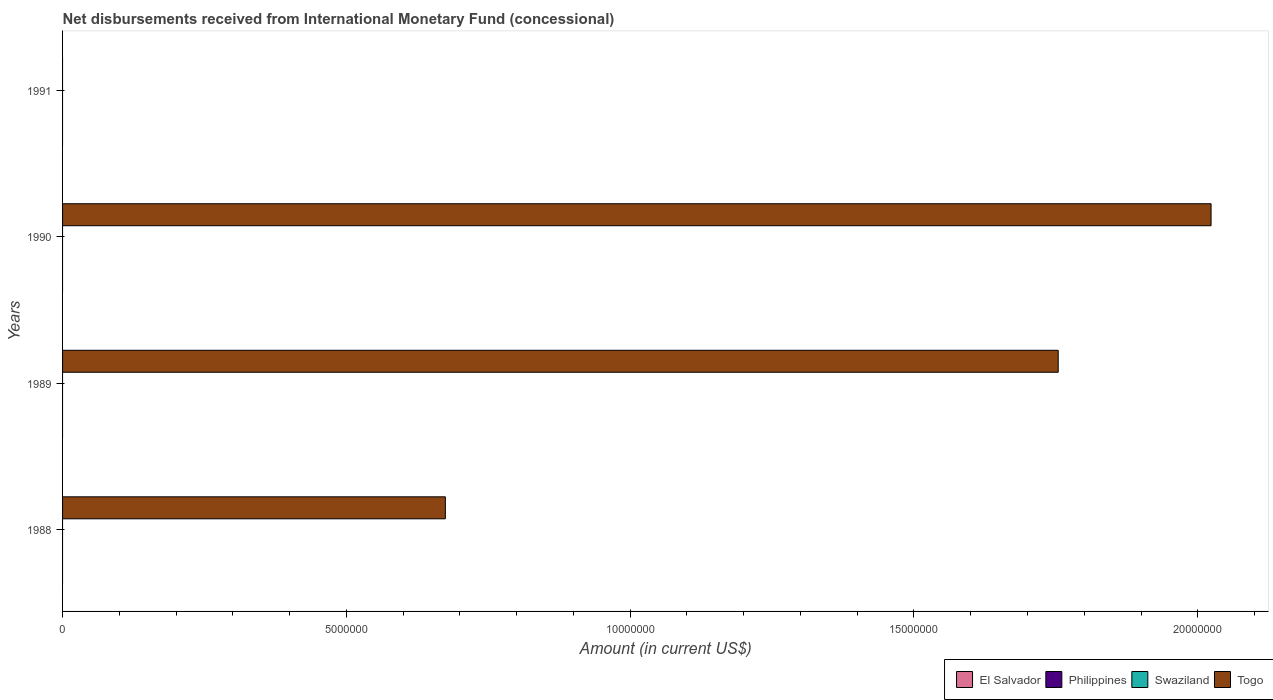How many different coloured bars are there?
Ensure brevity in your answer.  1. How many bars are there on the 1st tick from the bottom?
Ensure brevity in your answer.  1. What is the label of the 1st group of bars from the top?
Offer a terse response. 1991. Across all years, what is the maximum amount of disbursements received from International Monetary Fund in Togo?
Give a very brief answer. 2.02e+07. Across all years, what is the minimum amount of disbursements received from International Monetary Fund in Philippines?
Your answer should be compact. 0. What is the total amount of disbursements received from International Monetary Fund in El Salvador in the graph?
Provide a short and direct response. 0. What is the difference between the amount of disbursements received from International Monetary Fund in Swaziland in 1991 and the amount of disbursements received from International Monetary Fund in Togo in 1989?
Your response must be concise. -1.75e+07. What is the average amount of disbursements received from International Monetary Fund in Swaziland per year?
Provide a short and direct response. 0. What is the ratio of the amount of disbursements received from International Monetary Fund in Togo in 1989 to that in 1990?
Your response must be concise. 0.87. What is the difference between the highest and the second highest amount of disbursements received from International Monetary Fund in Togo?
Your answer should be compact. 2.69e+06. What is the difference between the highest and the lowest amount of disbursements received from International Monetary Fund in Togo?
Your answer should be compact. 2.02e+07. In how many years, is the amount of disbursements received from International Monetary Fund in Togo greater than the average amount of disbursements received from International Monetary Fund in Togo taken over all years?
Your answer should be compact. 2. Is it the case that in every year, the sum of the amount of disbursements received from International Monetary Fund in El Salvador and amount of disbursements received from International Monetary Fund in Swaziland is greater than the sum of amount of disbursements received from International Monetary Fund in Philippines and amount of disbursements received from International Monetary Fund in Togo?
Provide a short and direct response. No. Is it the case that in every year, the sum of the amount of disbursements received from International Monetary Fund in Philippines and amount of disbursements received from International Monetary Fund in El Salvador is greater than the amount of disbursements received from International Monetary Fund in Togo?
Your answer should be compact. No. How many bars are there?
Your answer should be very brief. 3. How many years are there in the graph?
Your response must be concise. 4. What is the difference between two consecutive major ticks on the X-axis?
Make the answer very short. 5.00e+06. Does the graph contain grids?
Your answer should be very brief. No. How are the legend labels stacked?
Make the answer very short. Horizontal. What is the title of the graph?
Ensure brevity in your answer.  Net disbursements received from International Monetary Fund (concessional). Does "Burkina Faso" appear as one of the legend labels in the graph?
Give a very brief answer. No. What is the Amount (in current US$) in El Salvador in 1988?
Provide a succinct answer. 0. What is the Amount (in current US$) in Philippines in 1988?
Your answer should be compact. 0. What is the Amount (in current US$) of Togo in 1988?
Provide a succinct answer. 6.74e+06. What is the Amount (in current US$) in Swaziland in 1989?
Ensure brevity in your answer.  0. What is the Amount (in current US$) in Togo in 1989?
Keep it short and to the point. 1.75e+07. What is the Amount (in current US$) in El Salvador in 1990?
Make the answer very short. 0. What is the Amount (in current US$) in Swaziland in 1990?
Provide a succinct answer. 0. What is the Amount (in current US$) of Togo in 1990?
Keep it short and to the point. 2.02e+07. What is the Amount (in current US$) in El Salvador in 1991?
Offer a terse response. 0. Across all years, what is the maximum Amount (in current US$) in Togo?
Ensure brevity in your answer.  2.02e+07. What is the total Amount (in current US$) in El Salvador in the graph?
Make the answer very short. 0. What is the total Amount (in current US$) of Togo in the graph?
Provide a short and direct response. 4.45e+07. What is the difference between the Amount (in current US$) in Togo in 1988 and that in 1989?
Ensure brevity in your answer.  -1.08e+07. What is the difference between the Amount (in current US$) in Togo in 1988 and that in 1990?
Provide a short and direct response. -1.35e+07. What is the difference between the Amount (in current US$) of Togo in 1989 and that in 1990?
Provide a succinct answer. -2.69e+06. What is the average Amount (in current US$) of El Salvador per year?
Your response must be concise. 0. What is the average Amount (in current US$) in Togo per year?
Offer a terse response. 1.11e+07. What is the ratio of the Amount (in current US$) in Togo in 1988 to that in 1989?
Ensure brevity in your answer.  0.38. What is the ratio of the Amount (in current US$) in Togo in 1989 to that in 1990?
Offer a very short reply. 0.87. What is the difference between the highest and the second highest Amount (in current US$) of Togo?
Ensure brevity in your answer.  2.69e+06. What is the difference between the highest and the lowest Amount (in current US$) in Togo?
Offer a very short reply. 2.02e+07. 